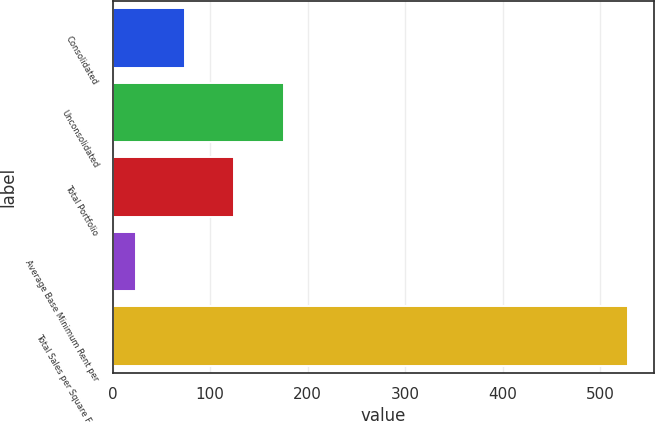<chart> <loc_0><loc_0><loc_500><loc_500><bar_chart><fcel>Consolidated<fcel>Unconsolidated<fcel>Total Portfolio<fcel>Average Base Minimum Rent per<fcel>Total Sales per Square Foot<nl><fcel>74.31<fcel>175.35<fcel>124.83<fcel>23.79<fcel>529<nl></chart> 